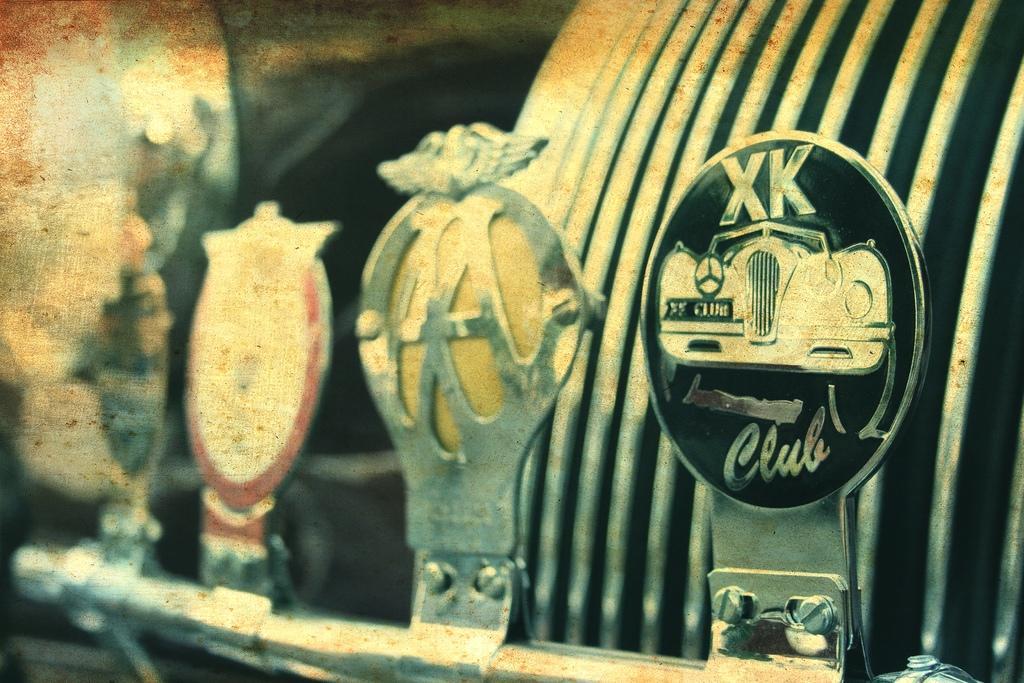How would you summarize this image in a sentence or two? In this image I can see few objects made up of metals. 